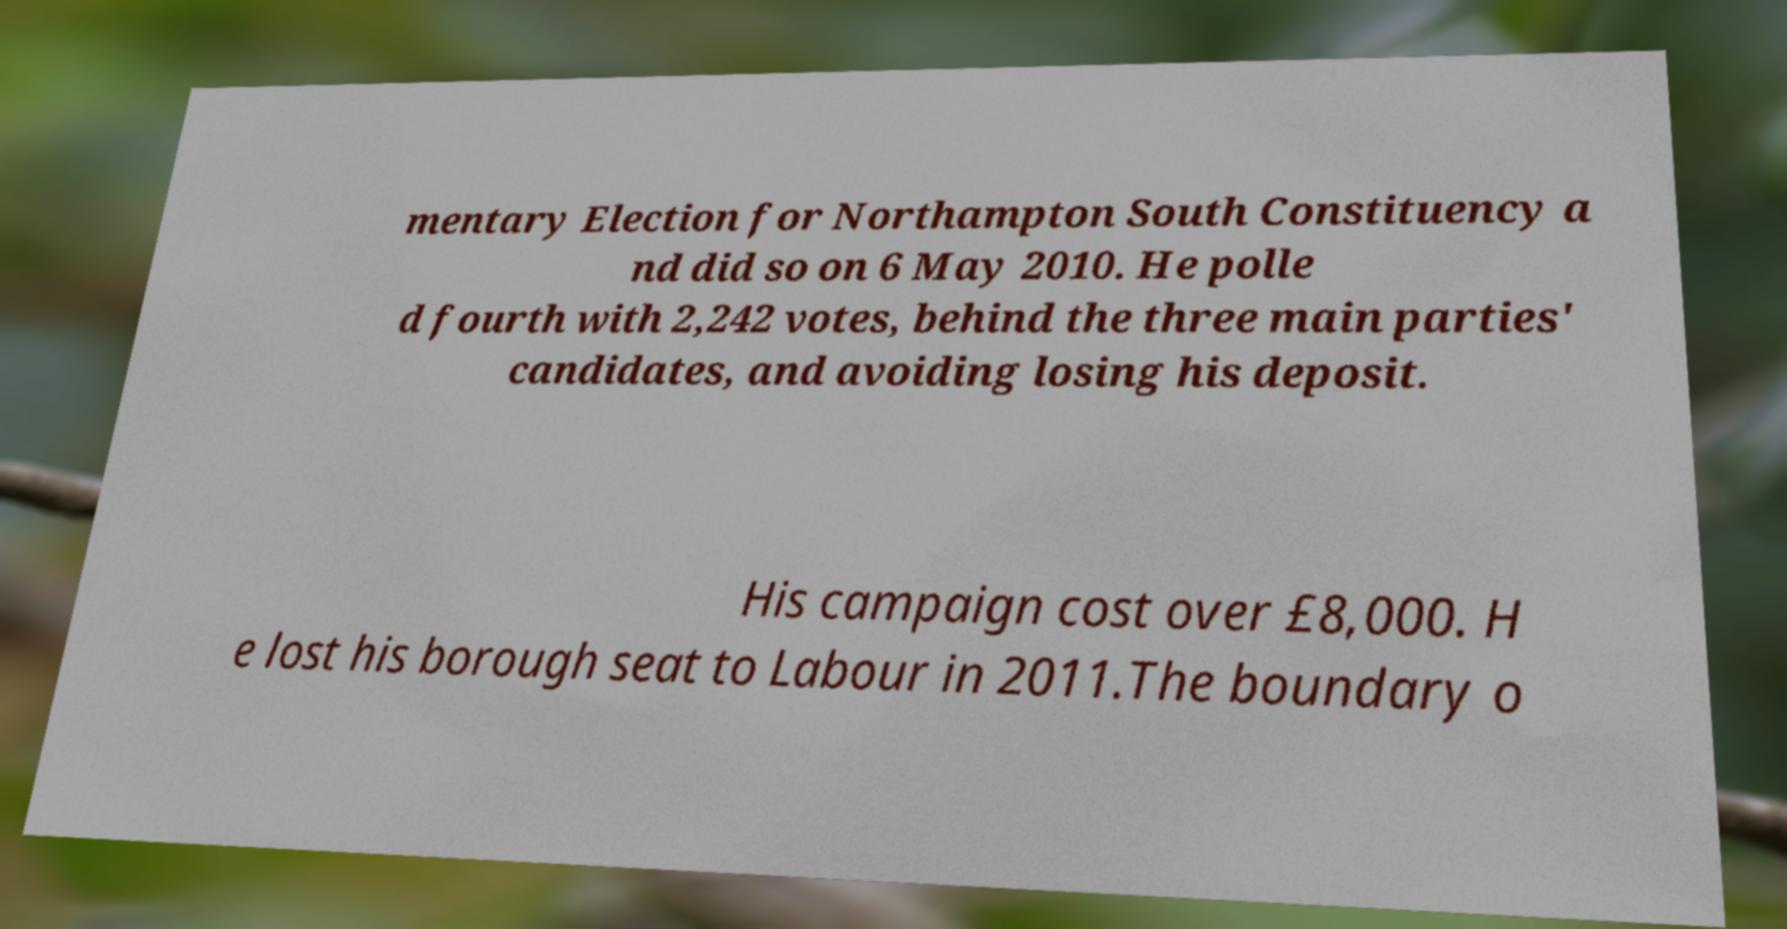Can you accurately transcribe the text from the provided image for me? mentary Election for Northampton South Constituency a nd did so on 6 May 2010. He polle d fourth with 2,242 votes, behind the three main parties' candidates, and avoiding losing his deposit. His campaign cost over £8,000. H e lost his borough seat to Labour in 2011.The boundary o 